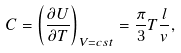Convert formula to latex. <formula><loc_0><loc_0><loc_500><loc_500>C = \left ( \frac { \partial U } { \partial T } \right ) _ { V = c s t } = \frac { \pi } { 3 } T \frac { l } { v } ,</formula> 